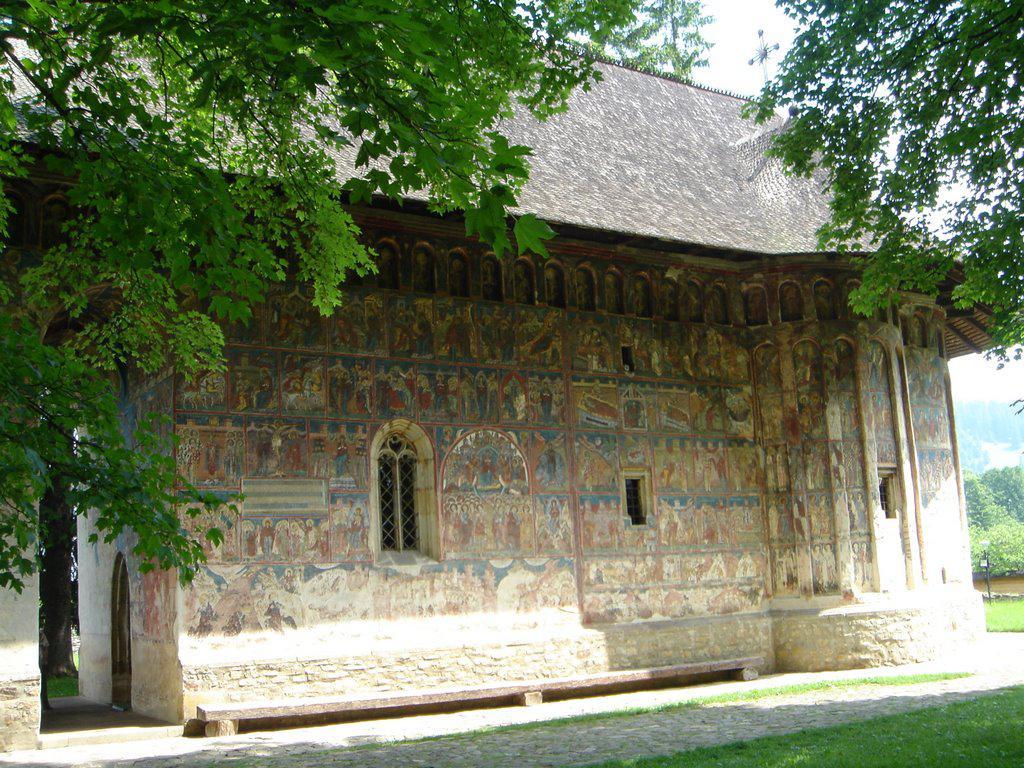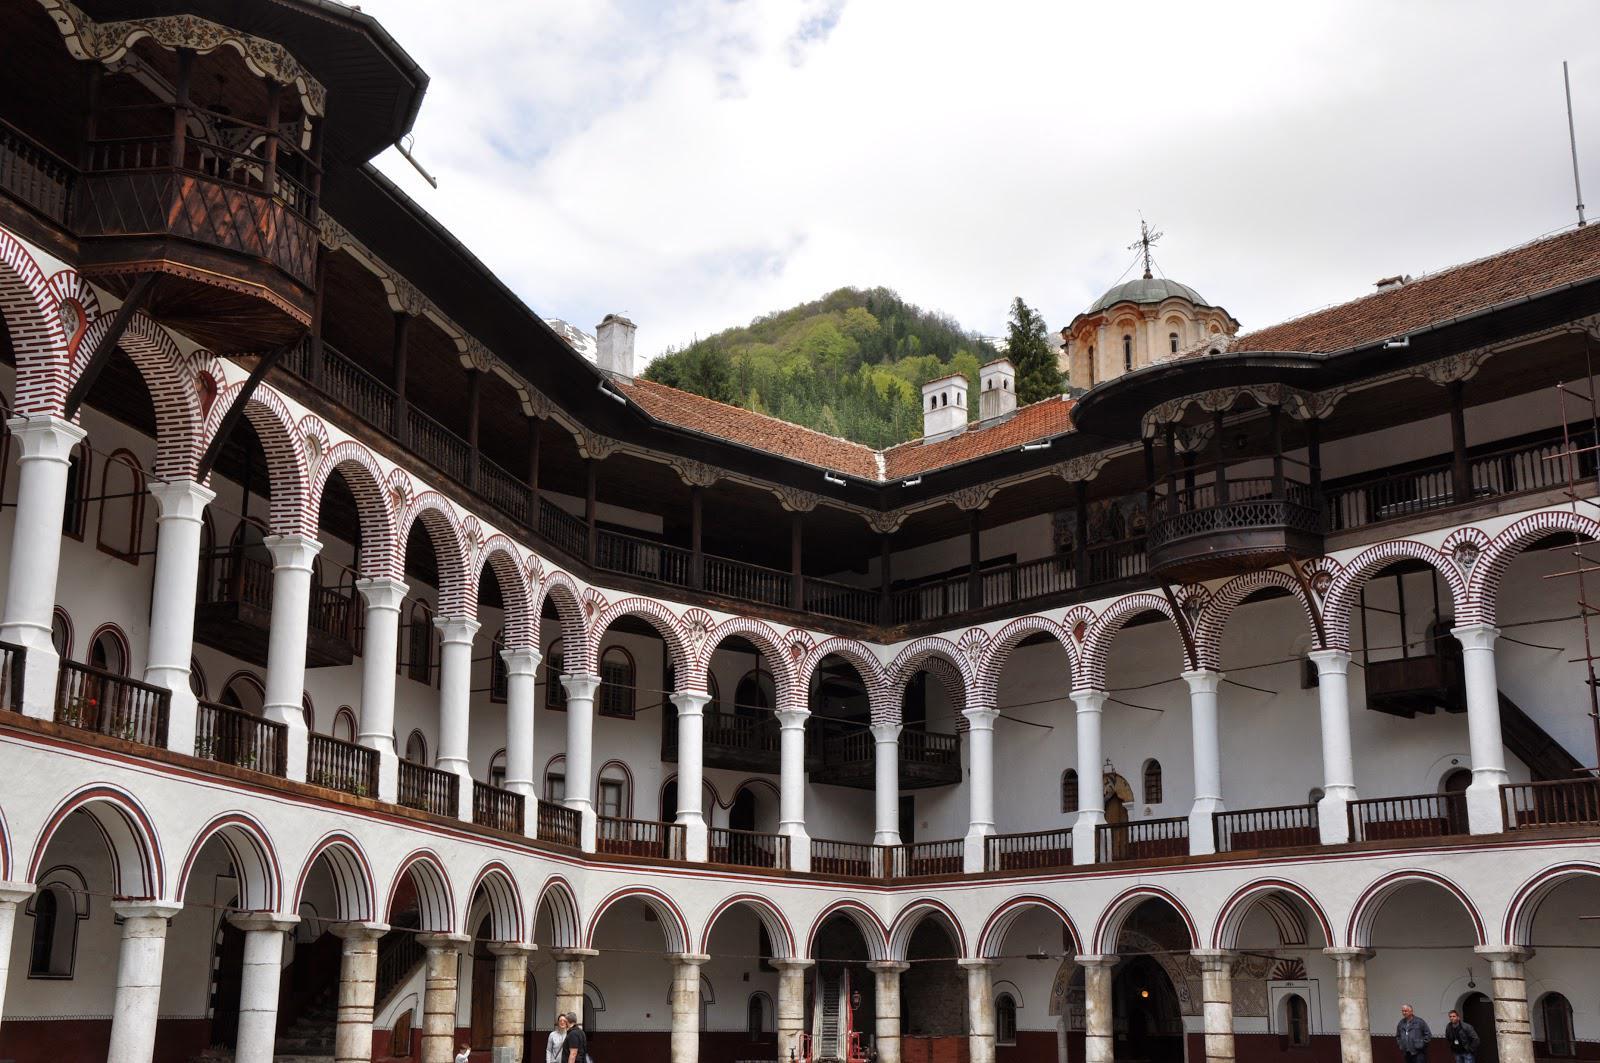The first image is the image on the left, the second image is the image on the right. Analyze the images presented: Is the assertion "The structure in the image on the right appears to have been hewn from the mountain." valid? Answer yes or no. No. 